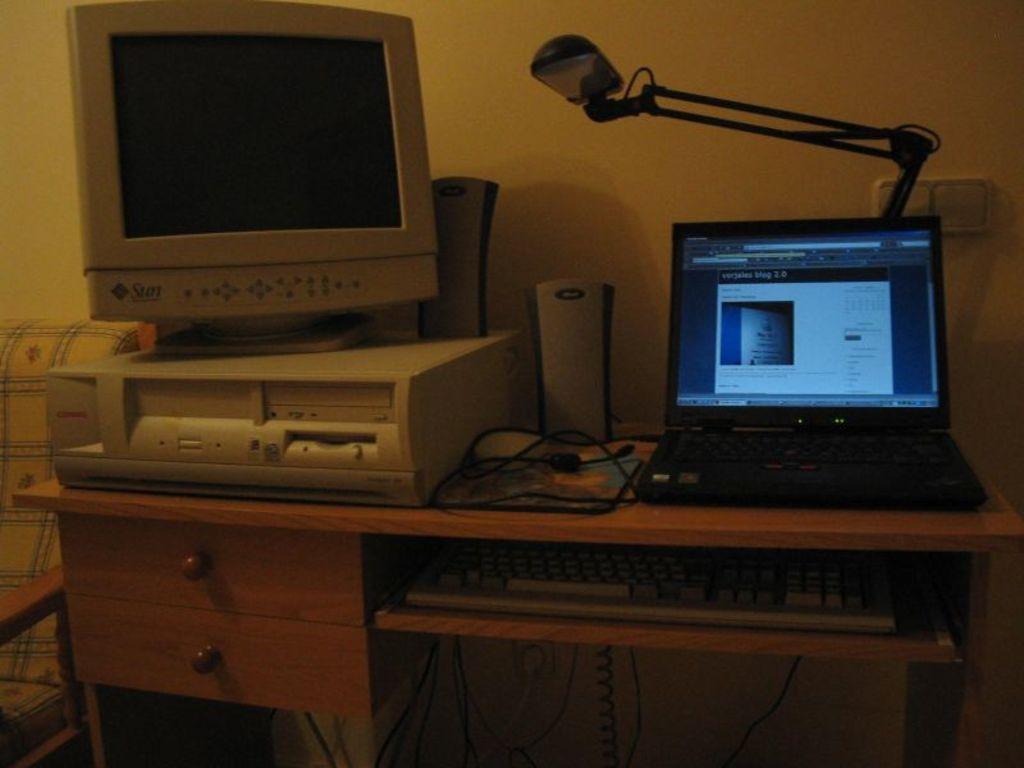How would you summarize this image in a sentence or two? In the image we can see there is a table on which there is a monitor and a laptop and a table lamp and speakers are kept and there is a keyboard which is attached to the stand. 